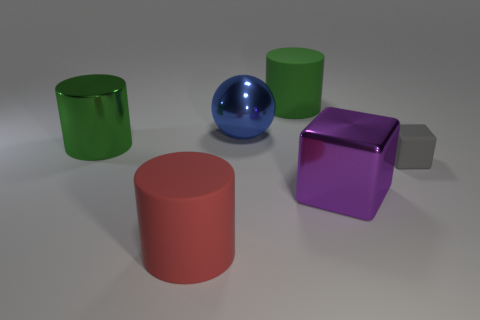Subtract all big matte cylinders. How many cylinders are left? 1 Add 2 matte objects. How many objects exist? 8 Subtract all cubes. How many objects are left? 4 Add 4 red things. How many red things are left? 5 Add 5 small matte blocks. How many small matte blocks exist? 6 Subtract 1 blue spheres. How many objects are left? 5 Subtract all tiny blue metal balls. Subtract all metallic things. How many objects are left? 3 